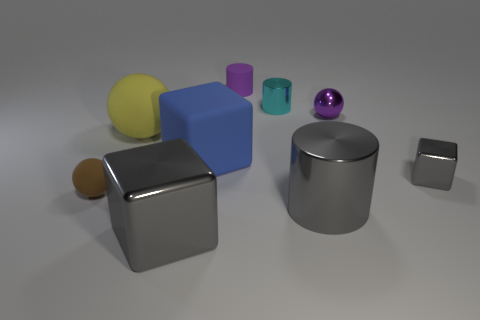What material is the tiny block that is the same color as the large metal block?
Make the answer very short. Metal. Are there any small objects that have the same color as the shiny sphere?
Ensure brevity in your answer.  Yes. Does the large cylinder have the same color as the big shiny block?
Provide a short and direct response. Yes. Is there anything else that has the same color as the tiny block?
Make the answer very short. Yes. There is a shiny block that is on the left side of the big cylinder; does it have the same color as the tiny metal block?
Provide a succinct answer. Yes. What material is the other tiny object that is the same shape as the small brown object?
Offer a very short reply. Metal. There is a metallic object that is both behind the big gray cylinder and left of the big cylinder; what size is it?
Provide a short and direct response. Small. There is a large yellow sphere to the right of the small brown thing; what is its material?
Your answer should be very brief. Rubber. There is a tiny matte cylinder; is it the same color as the sphere that is to the right of the purple cylinder?
Give a very brief answer. Yes. What number of things are either tiny spheres that are to the right of the big blue rubber thing or objects on the left side of the tiny block?
Your answer should be very brief. 8. 